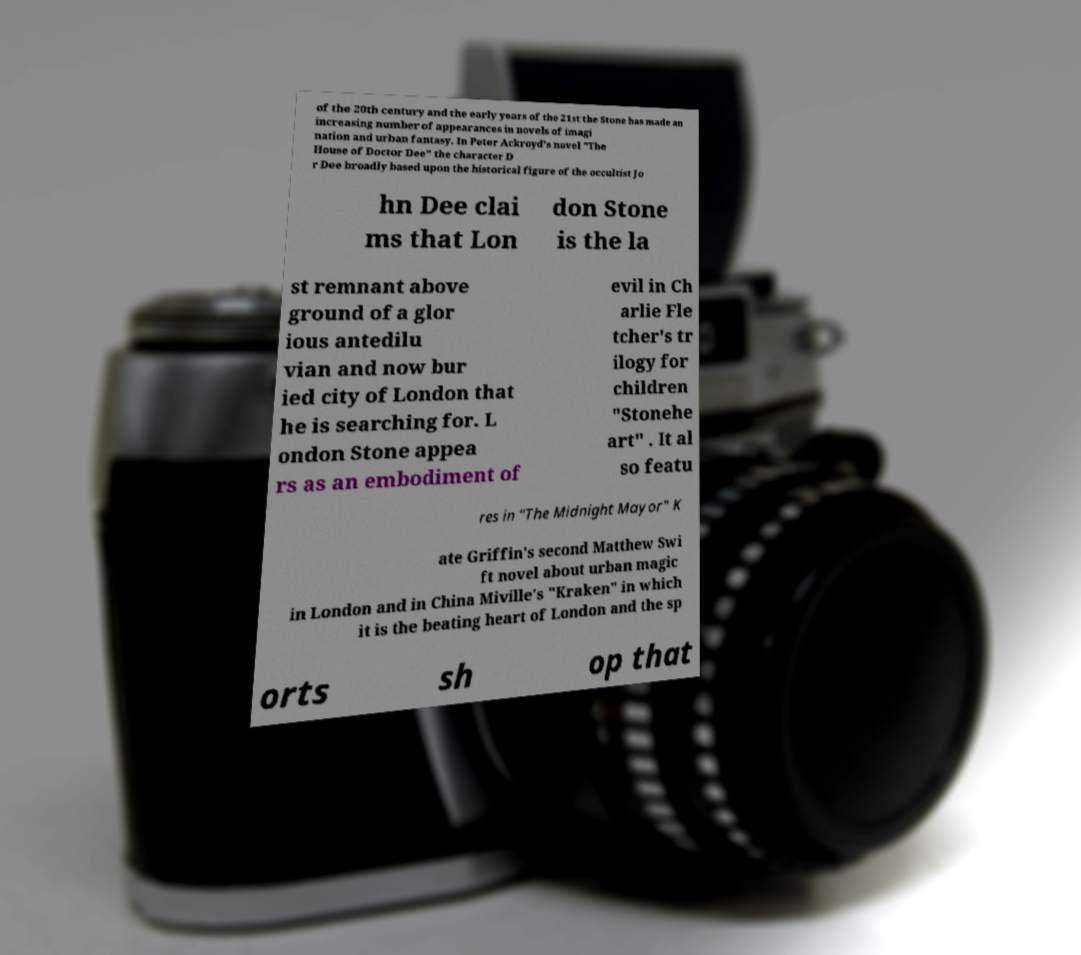Could you assist in decoding the text presented in this image and type it out clearly? of the 20th century and the early years of the 21st the Stone has made an increasing number of appearances in novels of imagi nation and urban fantasy. In Peter Ackroyd's novel "The House of Doctor Dee" the character D r Dee broadly based upon the historical figure of the occultist Jo hn Dee clai ms that Lon don Stone is the la st remnant above ground of a glor ious antedilu vian and now bur ied city of London that he is searching for. L ondon Stone appea rs as an embodiment of evil in Ch arlie Fle tcher's tr ilogy for children "Stonehe art" . It al so featu res in "The Midnight Mayor" K ate Griffin's second Matthew Swi ft novel about urban magic in London and in China Miville's "Kraken" in which it is the beating heart of London and the sp orts sh op that 